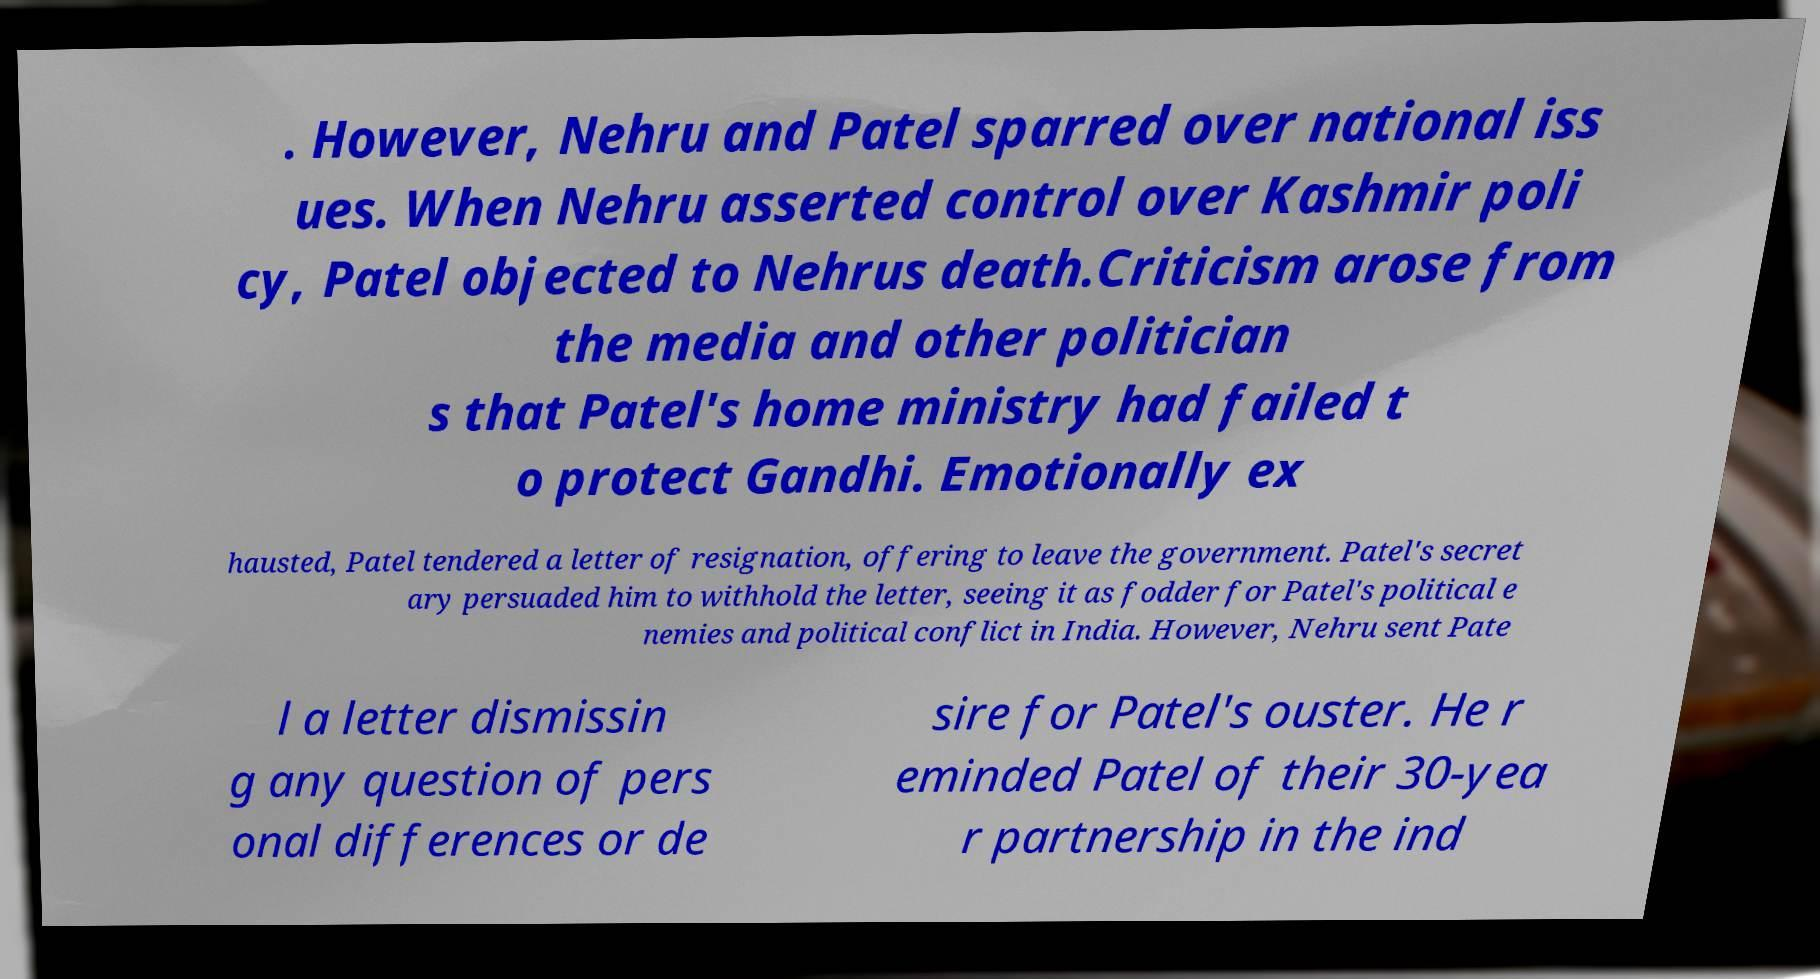For documentation purposes, I need the text within this image transcribed. Could you provide that? . However, Nehru and Patel sparred over national iss ues. When Nehru asserted control over Kashmir poli cy, Patel objected to Nehrus death.Criticism arose from the media and other politician s that Patel's home ministry had failed t o protect Gandhi. Emotionally ex hausted, Patel tendered a letter of resignation, offering to leave the government. Patel's secret ary persuaded him to withhold the letter, seeing it as fodder for Patel's political e nemies and political conflict in India. However, Nehru sent Pate l a letter dismissin g any question of pers onal differences or de sire for Patel's ouster. He r eminded Patel of their 30-yea r partnership in the ind 